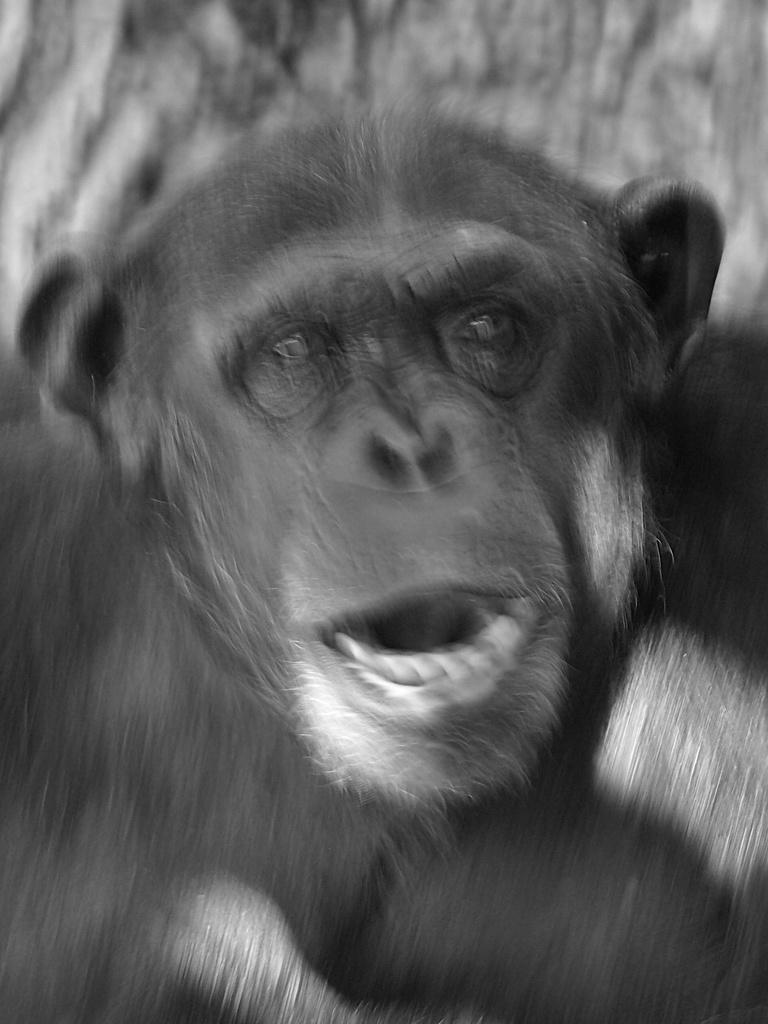What type of animal is in the image? There is a chimpanzee in the image. How many cars are parked next to the chimpanzee in the image? There are no cars present in the image; it features a chimpanzee. What type of light source is illuminating the chimpanzee in the image? There is no specific light source mentioned or visible in the image; it simply features a chimpanzee. 